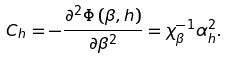<formula> <loc_0><loc_0><loc_500><loc_500>C _ { h } = - \frac { \partial ^ { 2 } \Phi \left ( \beta , h \right ) } { \partial \beta ^ { 2 } } = \chi _ { \beta } ^ { - 1 } \alpha _ { h } ^ { 2 } .</formula> 